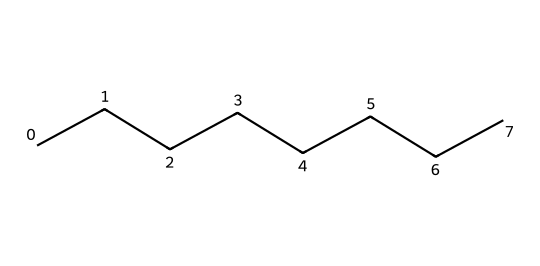What is the name of the chemical represented by the SMILES? The SMILES "CCCCCCCC" represents a straight-chain hydrocarbon with eight carbon atoms, which is known as octane.
Answer: octane How many carbon atoms are in this molecule? By counting each "C" in the SMILES "CCCCCCCC," we can see there are a total of eight carbon atoms.
Answer: 8 How many hydrogen atoms are associated with this hydrocarbon? For a straight-chain alkane like octane, the formula is CnH(2n+2). Using n=8, we calculate the hydrogen atoms: 2(8)+2 = 18.
Answer: 18 What type of hydrocarbon is represented here? Since the chemical structure is composed entirely of carbon and hydrogen atoms and contains only single bonds, it is classified as an alkane.
Answer: alkane What is the molecular formula for octane? The molecular formula is derived from the number of carbon and hydrogen atoms, specifically C8H18, representing the specific alkane configuration.
Answer: C8H18 What property of octane is important for hair shine serums? Octane is a saturated hydrocarbon, which contributes to its emollient properties, making it useful for providing shine and moisture in hair care products.
Answer: emollient 